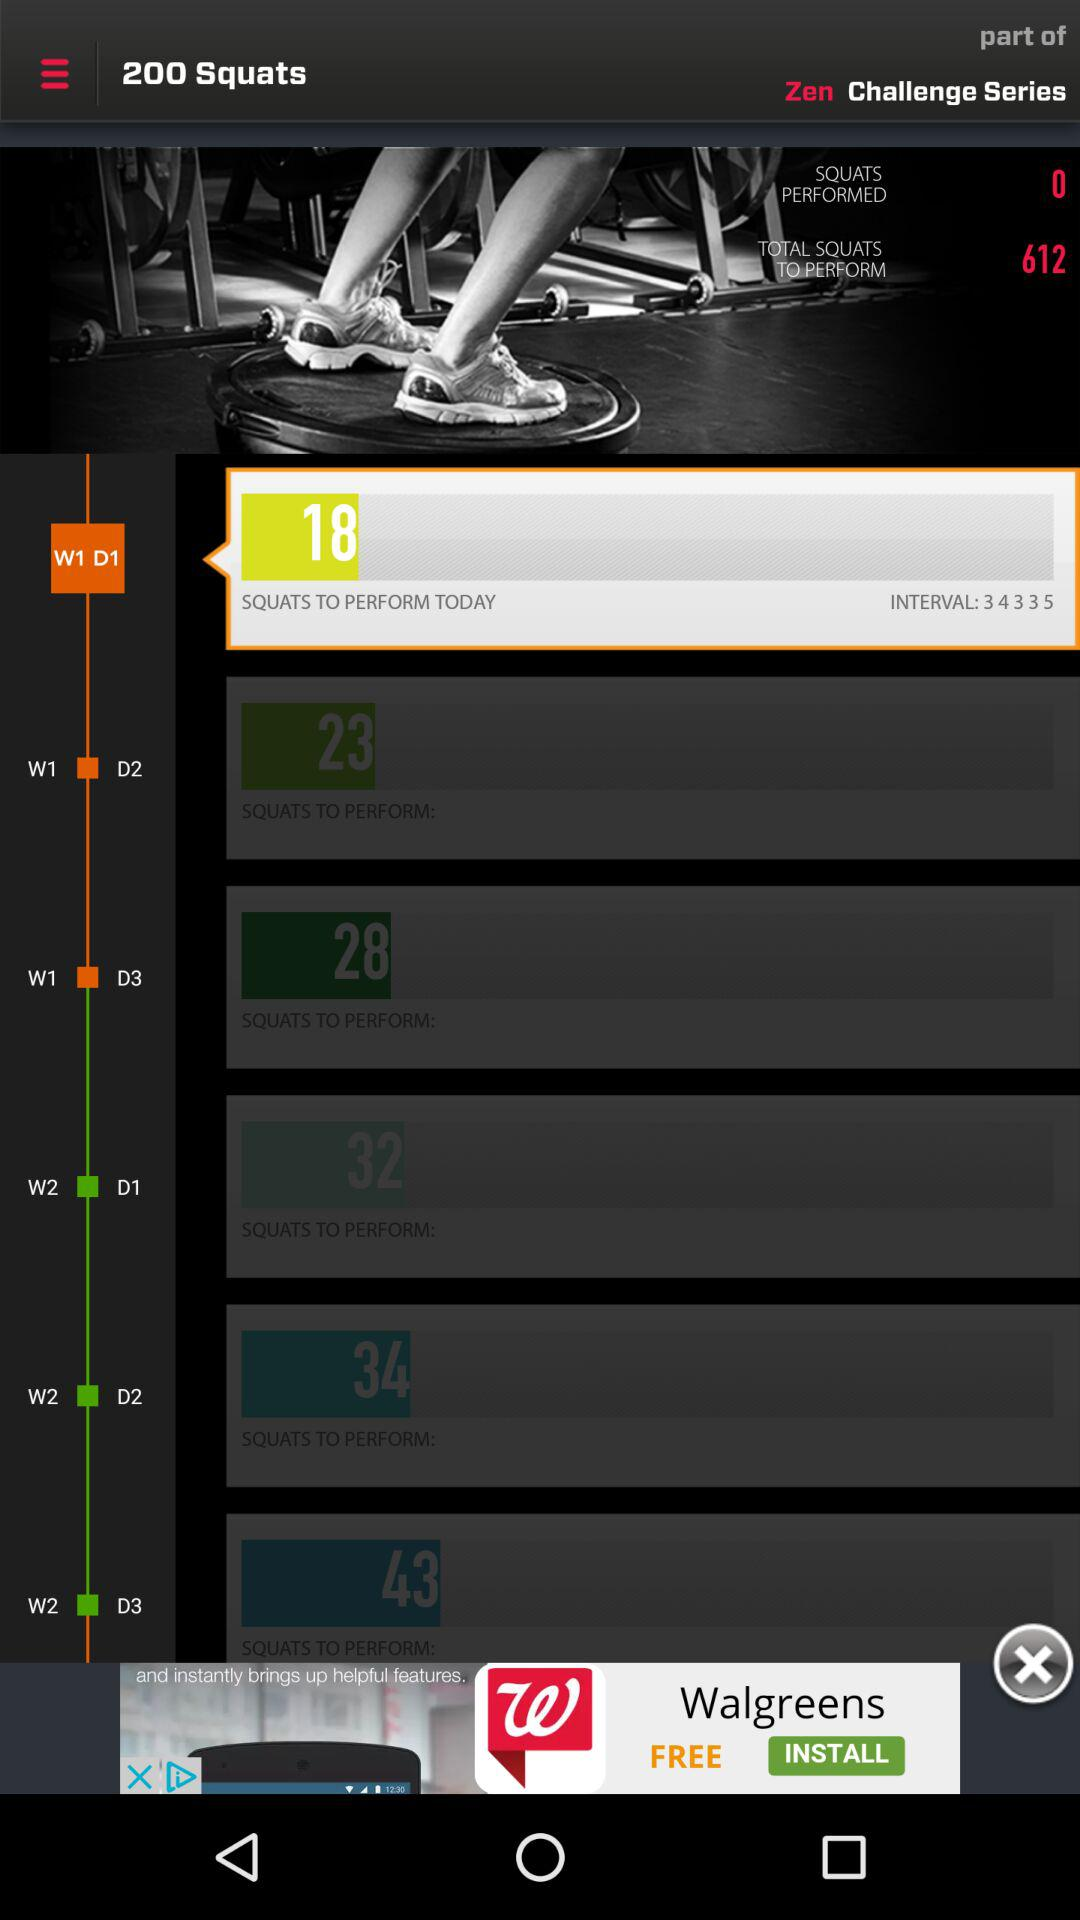How many squats in total are there to perform? There are 612 squats to perform. 